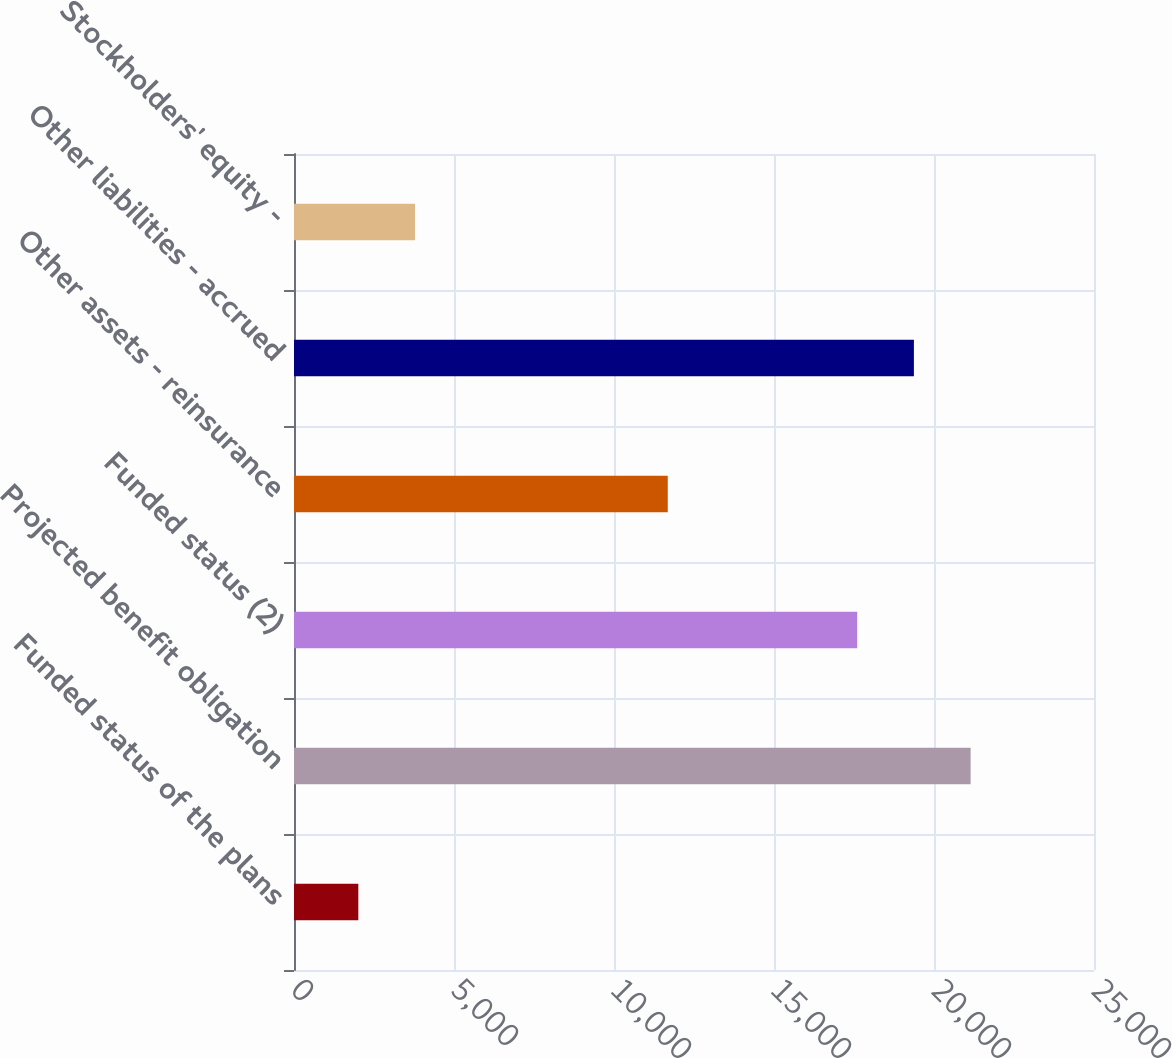Convert chart. <chart><loc_0><loc_0><loc_500><loc_500><bar_chart><fcel>Funded status of the plans<fcel>Projected benefit obligation<fcel>Funded status (2)<fcel>Other assets - reinsurance<fcel>Other liabilities - accrued<fcel>Stockholders' equity -<nl><fcel>2010<fcel>21144<fcel>17600<fcel>11680<fcel>19372<fcel>3782<nl></chart> 